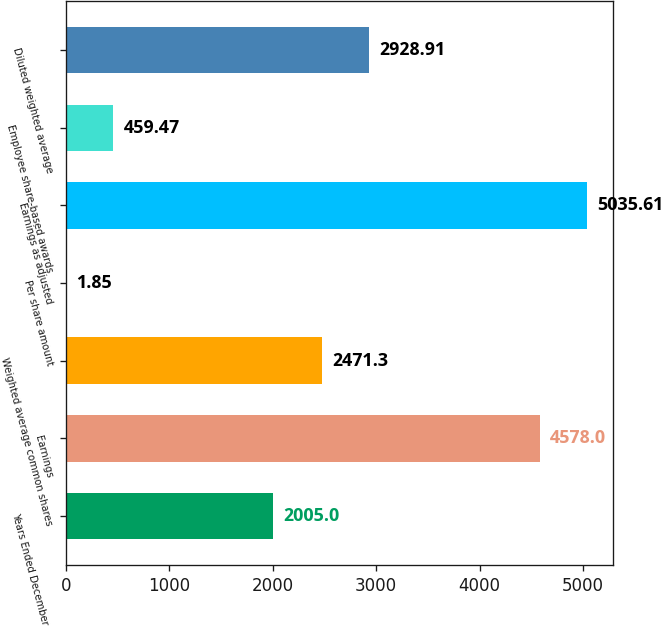Convert chart. <chart><loc_0><loc_0><loc_500><loc_500><bar_chart><fcel>Years Ended December 31<fcel>Earnings<fcel>Weighted average common shares<fcel>Per share amount<fcel>Earnings as adjusted<fcel>Employee share-based awards<fcel>Diluted weighted average<nl><fcel>2005<fcel>4578<fcel>2471.3<fcel>1.85<fcel>5035.61<fcel>459.47<fcel>2928.91<nl></chart> 